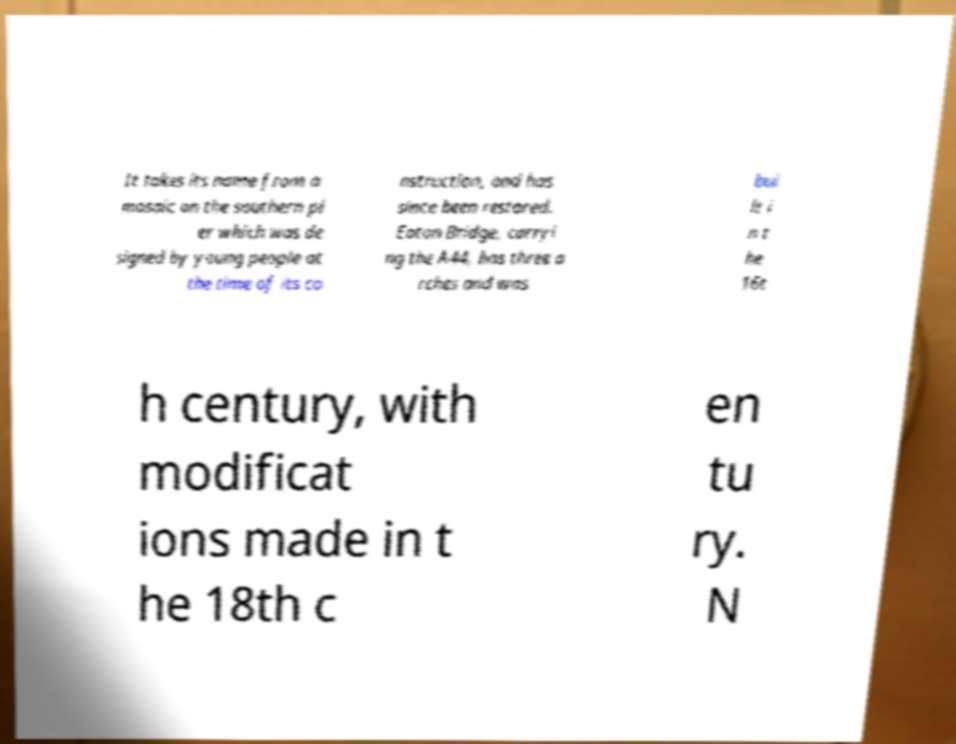Please identify and transcribe the text found in this image. It takes its name from a mosaic on the southern pi er which was de signed by young people at the time of its co nstruction, and has since been restored. Eaton Bridge, carryi ng the A44, has three a rches and was bui lt i n t he 16t h century, with modificat ions made in t he 18th c en tu ry. N 